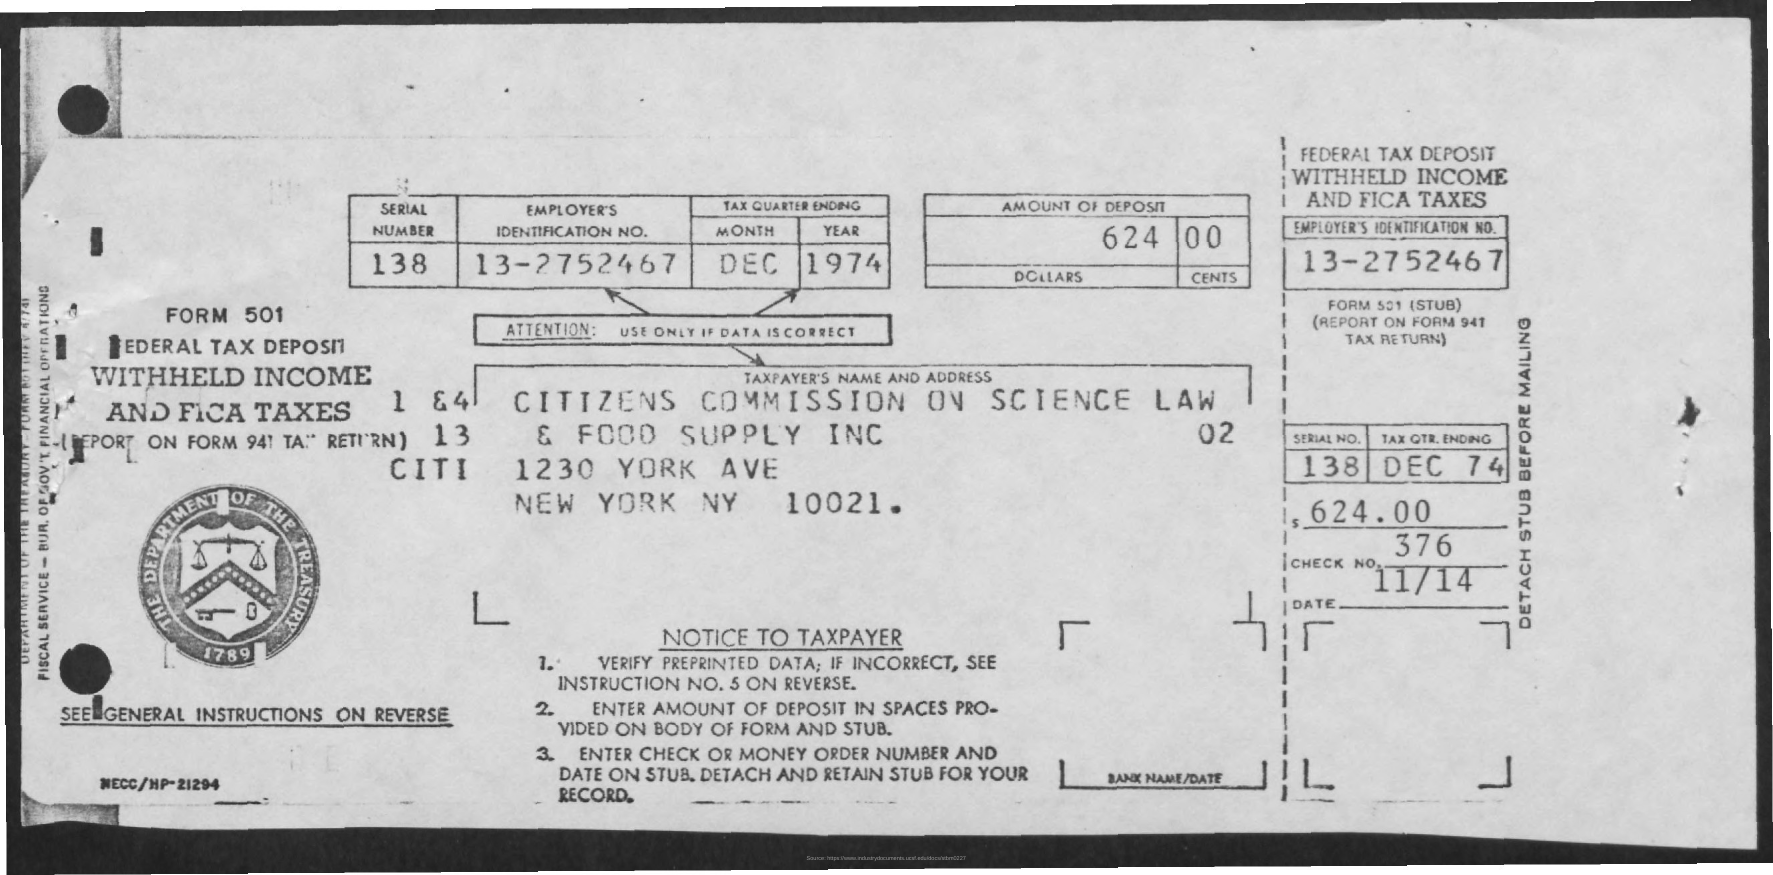What information is required on this form? The form requires the employer's identification number, the serial number, the tax quarter ending date, the amount of withheld income and FICA taxes being deposited, and the name and address of the taxpayer or employer making the deposit. 